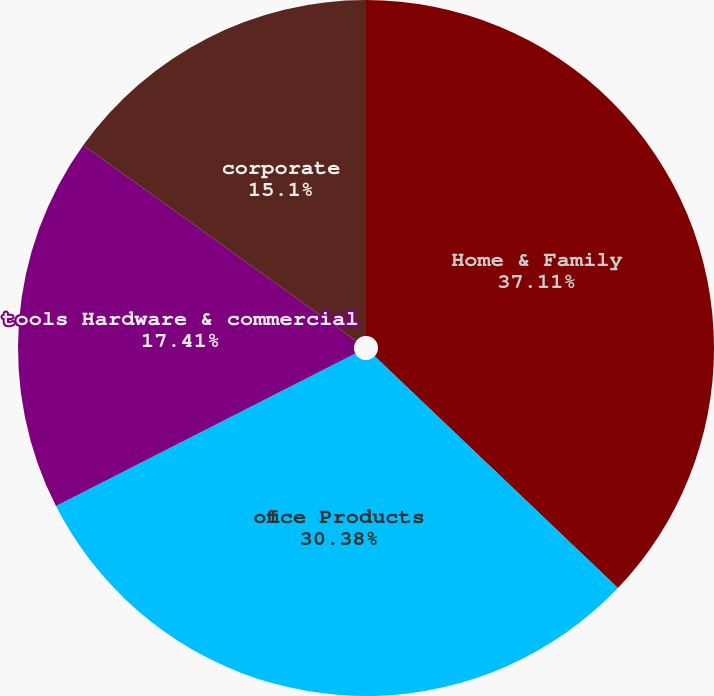Convert chart to OTSL. <chart><loc_0><loc_0><loc_500><loc_500><pie_chart><fcel>Home & Family<fcel>office Products<fcel>tools Hardware & commercial<fcel>corporate<nl><fcel>37.12%<fcel>30.38%<fcel>17.41%<fcel>15.1%<nl></chart> 